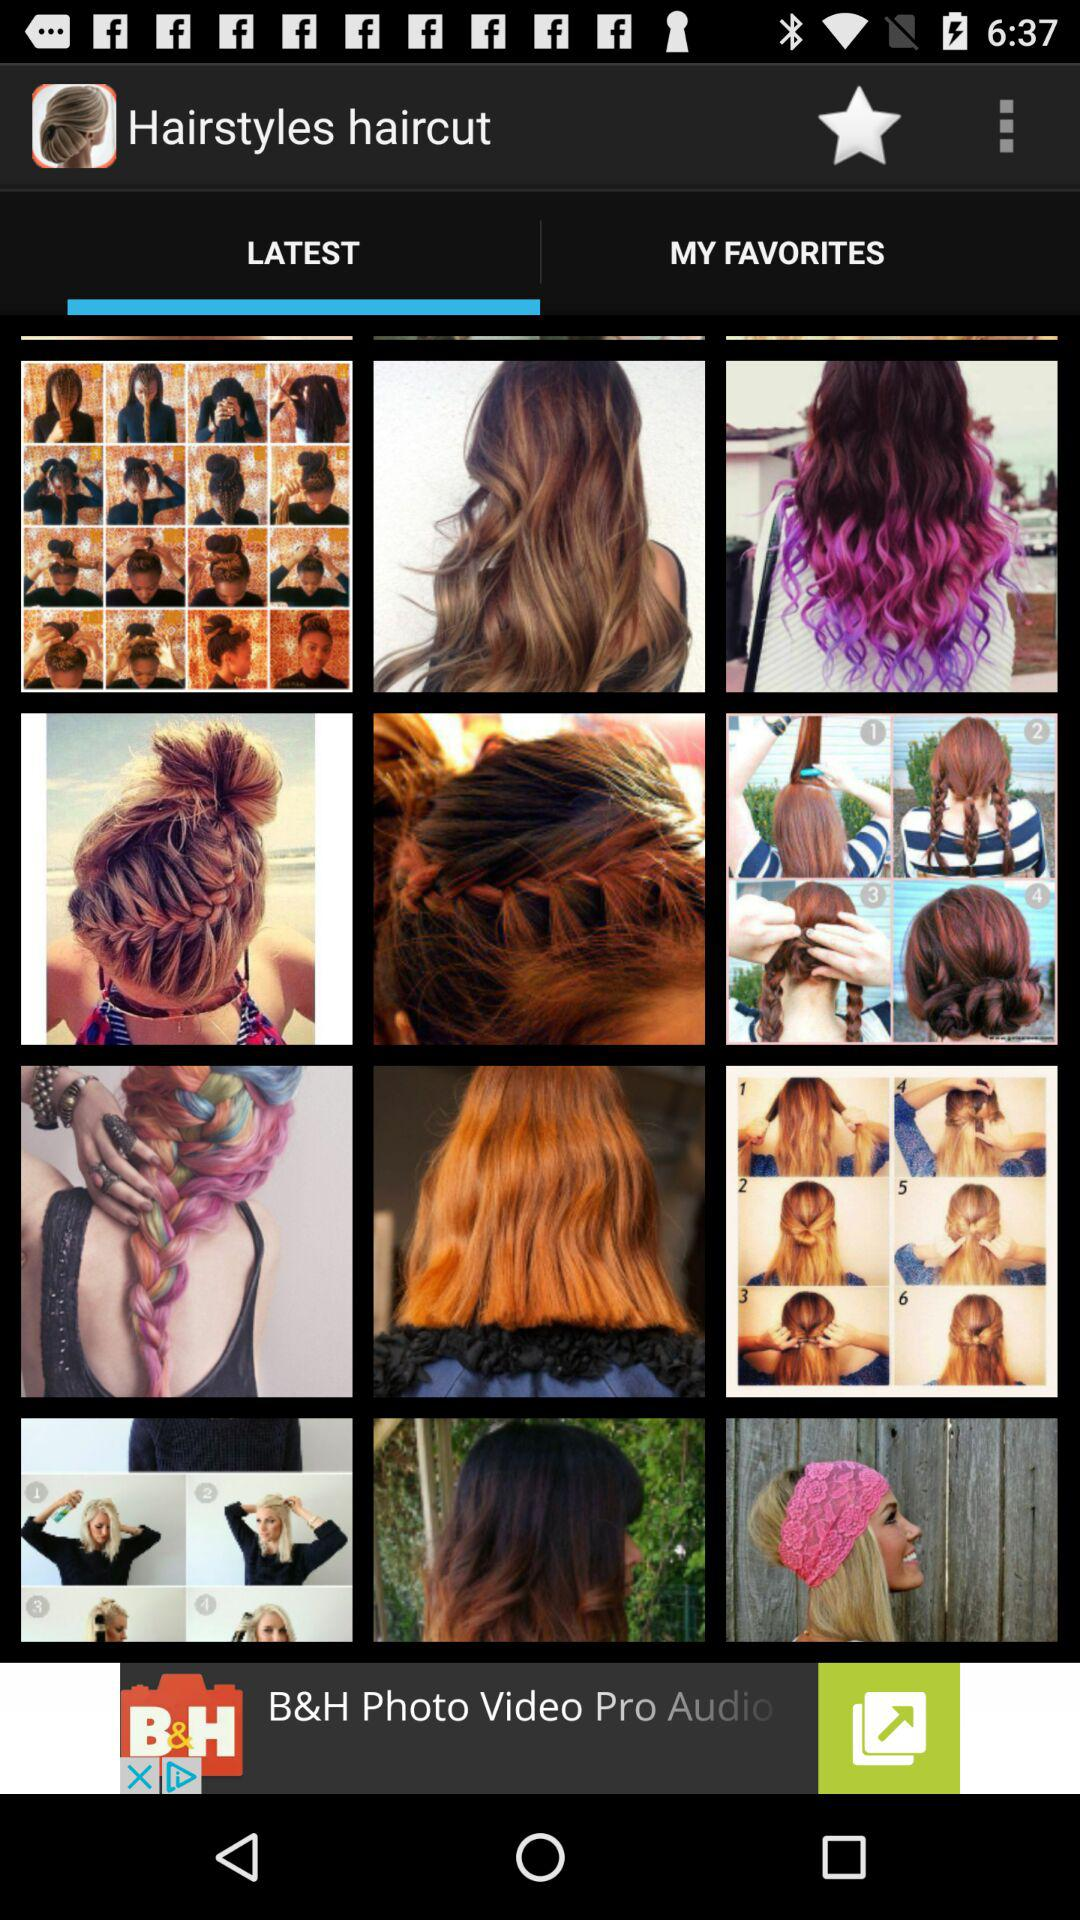What is the app's name? The app's name is "Hairstyles haircut". 